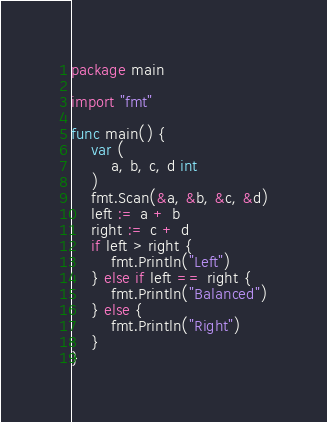<code> <loc_0><loc_0><loc_500><loc_500><_Go_>package main

import "fmt"

func main() {
	var (
		a, b, c, d int
	)
	fmt.Scan(&a, &b, &c, &d)
	left := a + b
	right := c + d
	if left > right {
		fmt.Println("Left")
	} else if left == right {
		fmt.Println("Balanced")
	} else {
		fmt.Println("Right")
	}
}
</code> 